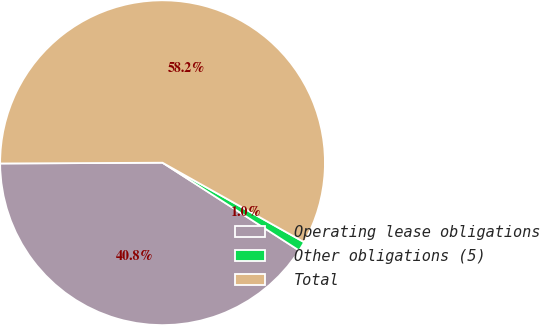<chart> <loc_0><loc_0><loc_500><loc_500><pie_chart><fcel>Operating lease obligations<fcel>Other obligations (5)<fcel>Total<nl><fcel>40.83%<fcel>0.95%<fcel>58.21%<nl></chart> 